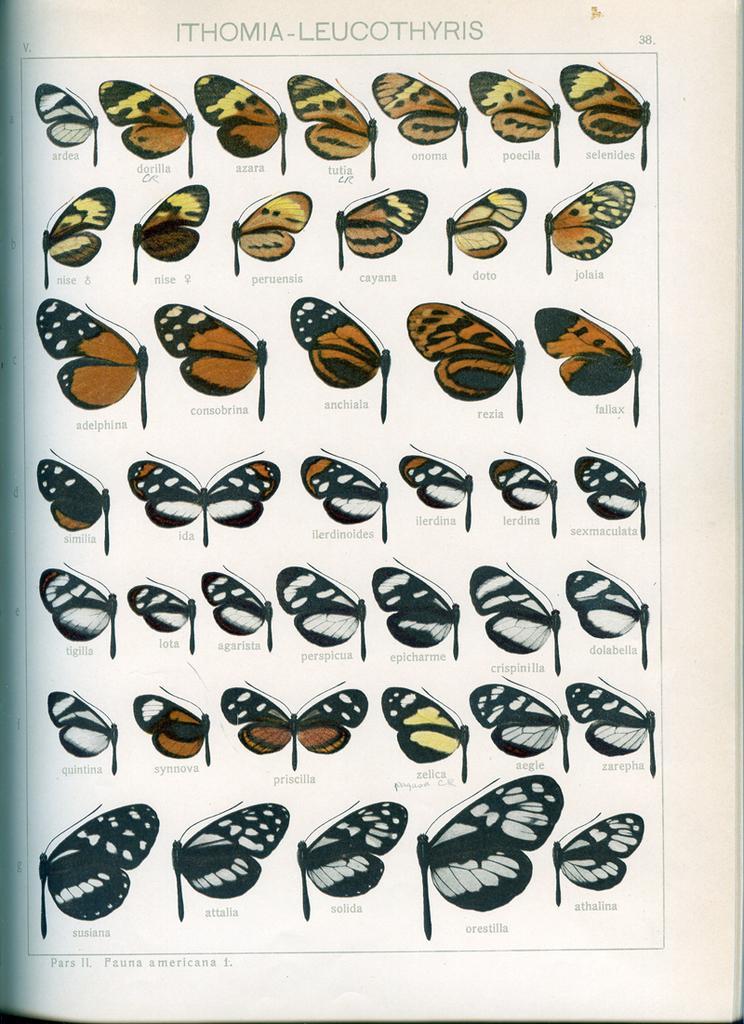In one or two sentences, can you explain what this image depicts? The image consists of a page might be from a book, in this picture we can see various catalog of butterflies. At the top there is text. 